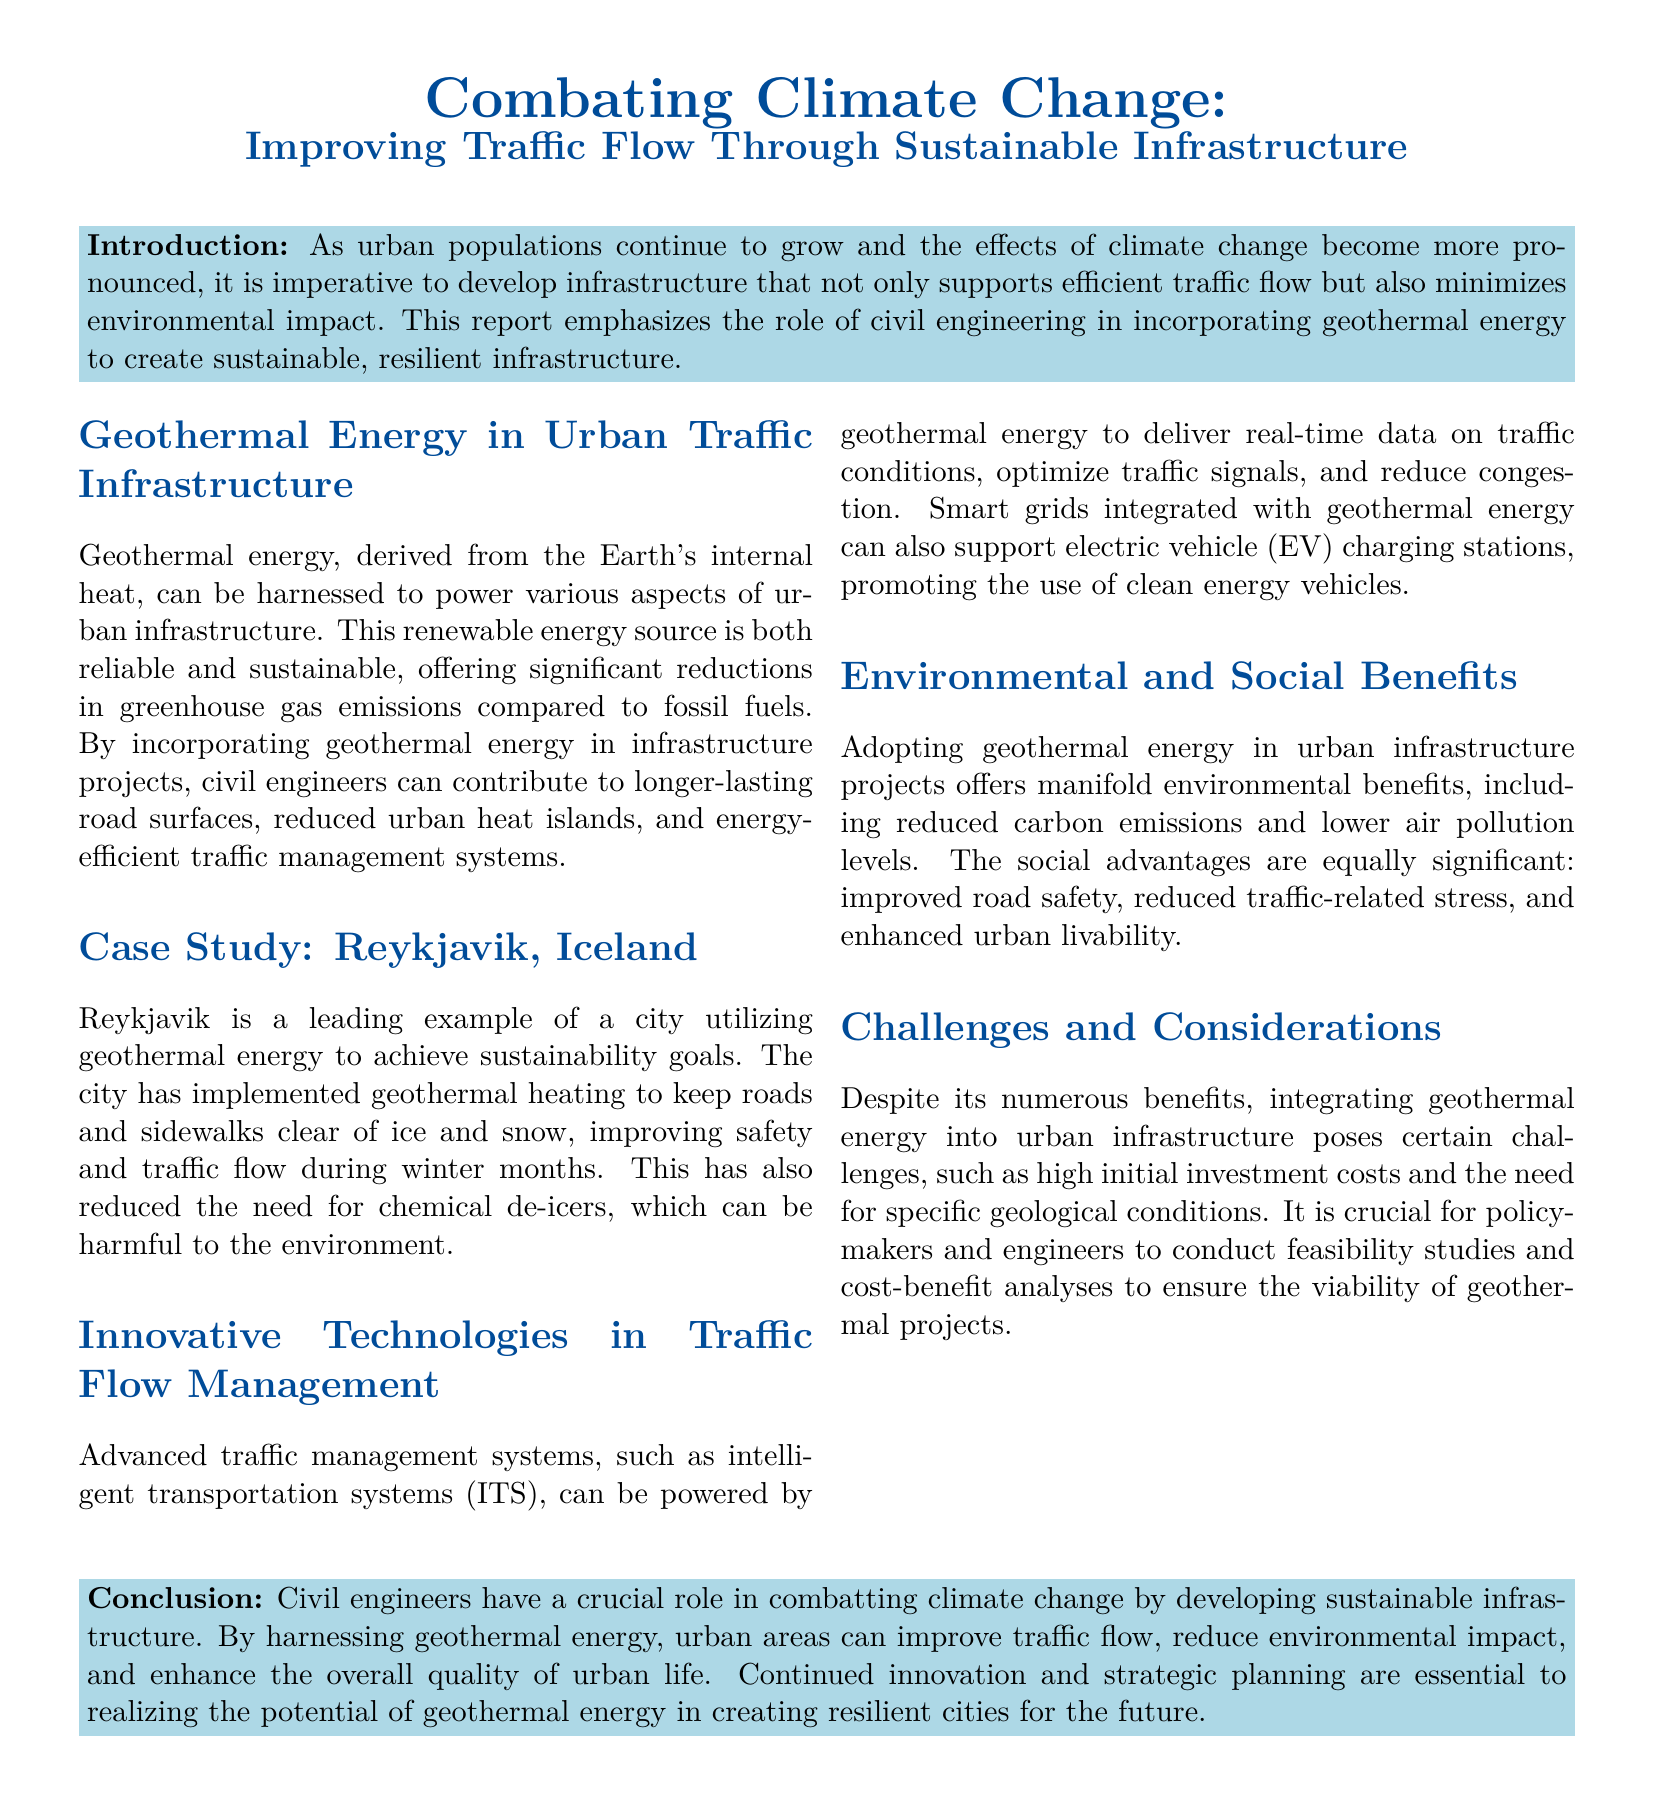What is the main focus of the report? The report emphasizes developing infrastructure that supports efficient traffic flow and minimizes environmental impact.
Answer: Sustainable infrastructure What energy source is highlighted in the document? The report discusses the use of geothermal energy derived from the Earth's internal heat.
Answer: Geothermal energy What is one city mentioned that utilizes geothermal energy? The case study provides an example of Reykjavik, Iceland, which successfully implements geothermal energy in urban infrastructure.
Answer: Reykjavik What is a benefit of using geothermal energy in urban infrastructure? Geothermal energy offers significant reductions in greenhouse gas emissions compared to fossil fuels.
Answer: Reduced emissions What system can be powered by geothermal energy for traffic management? Intelligent transportation systems (ITS) can be powered by geothermal energy to optimize traffic conditions.
Answer: Intelligent transportation systems What are two environmental benefits mentioned in the document? Adopting geothermal energy reduces carbon emissions and lowers air pollution levels.
Answer: Reduced carbon emissions, lower air pollution What is a challenge associated with integrating geothermal energy? The report identifies high initial investment costs as one of the challenges in implementing geothermal energy.
Answer: High initial investment costs In what way can geothermal heating improve winter traffic conditions? Geothermal heating keeps roads and sidewalks clear of ice and snow, enhancing safety and traffic flow.
Answer: Keeps roads clear of ice What is one social benefit of utilizing geothermal energy in urban areas? Improved road safety is highlighted as one of the social advantages of employing geothermal energy.
Answer: Improved road safety 